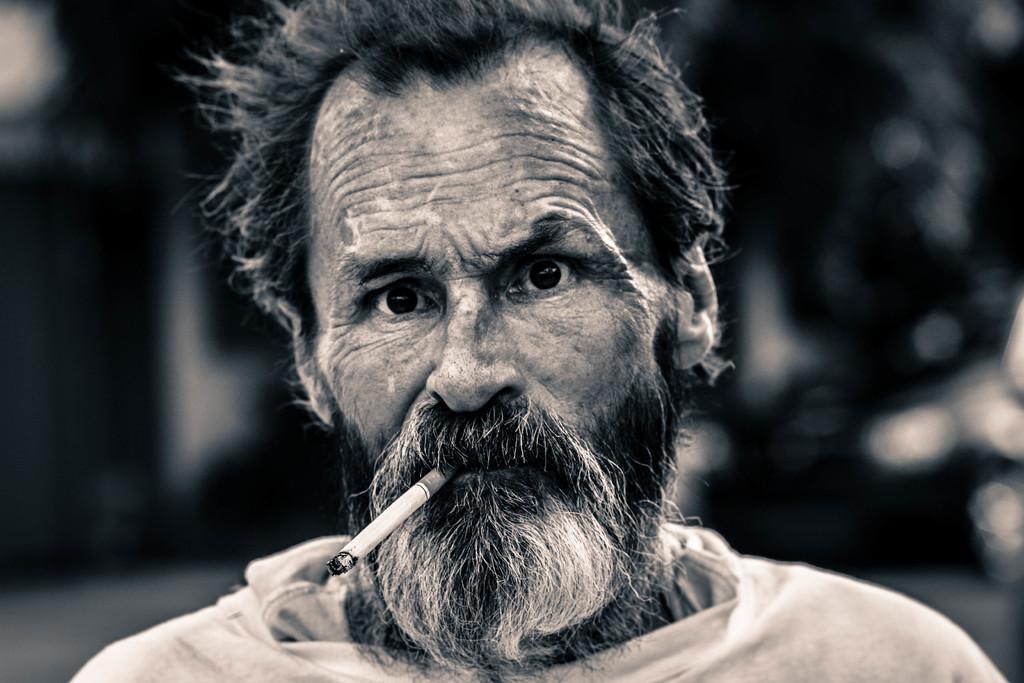Can you describe this image briefly? In this image in front there is a person holding the cigarette in his mouth and the background of the image is blur. 